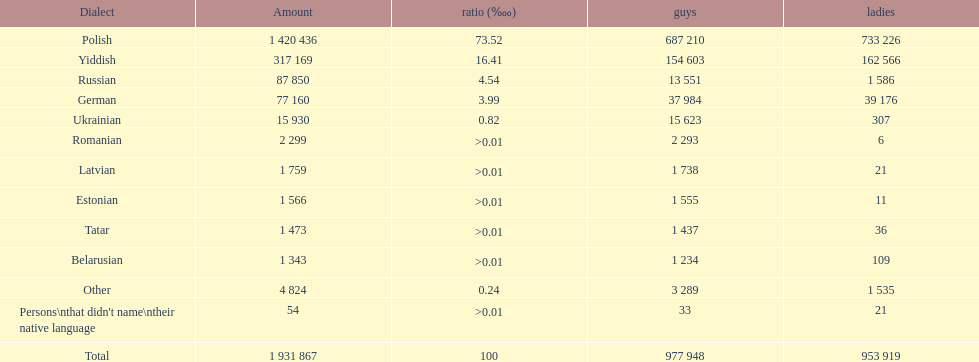What was the leading language among those with a percentage greater than Romanian. 